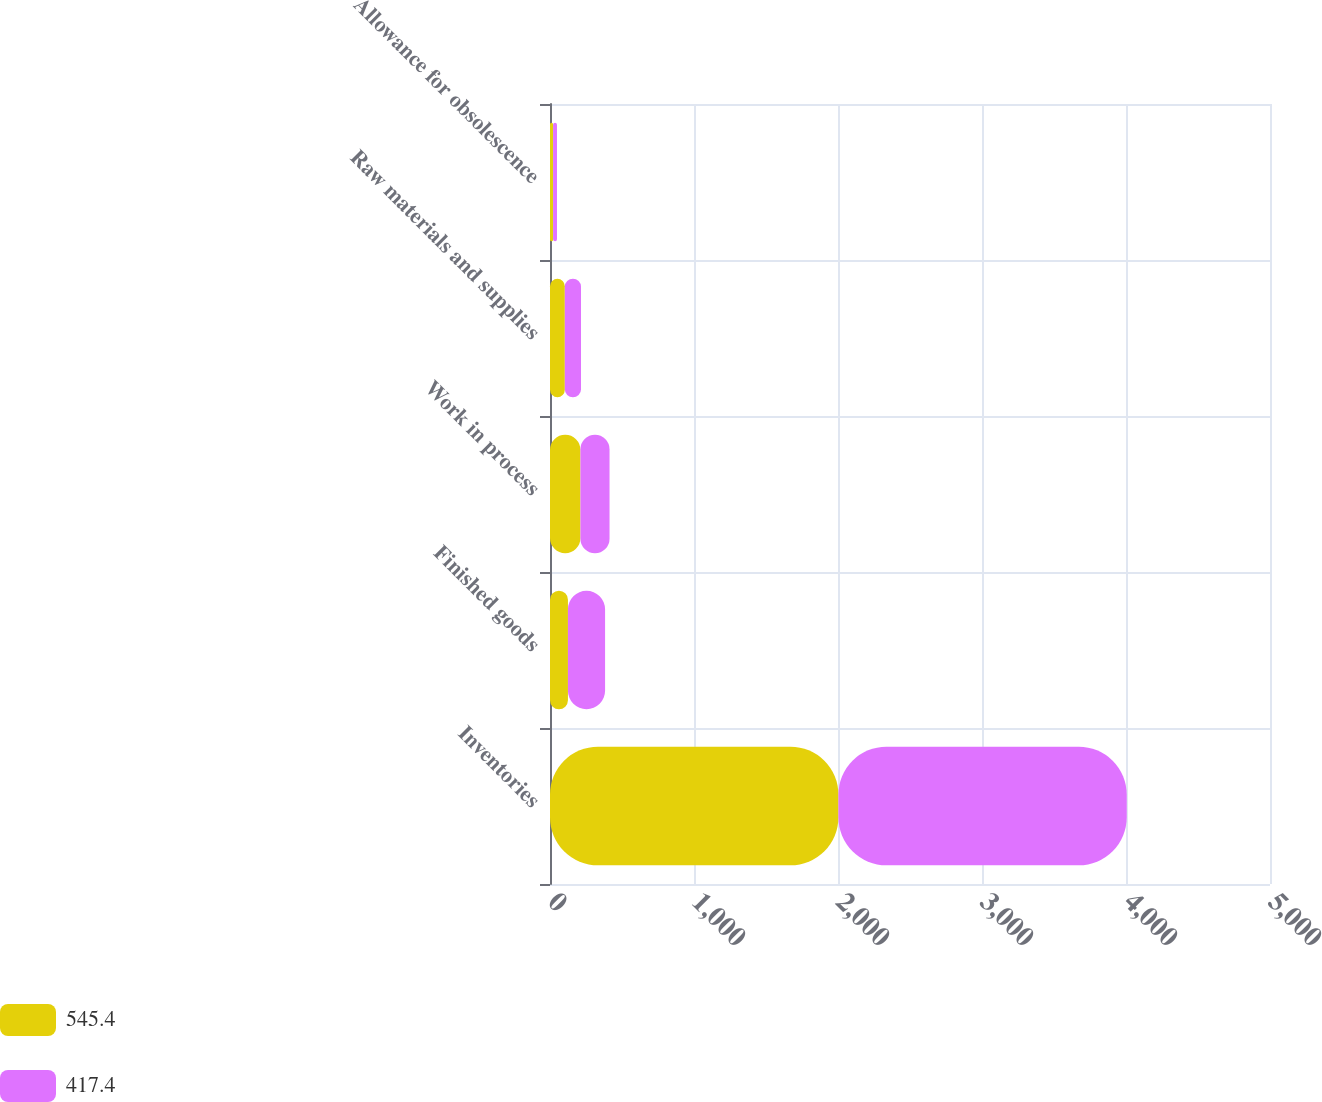Convert chart to OTSL. <chart><loc_0><loc_0><loc_500><loc_500><stacked_bar_chart><ecel><fcel>Inventories<fcel>Finished goods<fcel>Work in process<fcel>Raw materials and supplies<fcel>Allowance for obsolescence<nl><fcel>545.4<fcel>2003<fcel>124.6<fcel>211.3<fcel>102.9<fcel>21.4<nl><fcel>417.4<fcel>2002<fcel>257.9<fcel>202.2<fcel>112.4<fcel>27.1<nl></chart> 